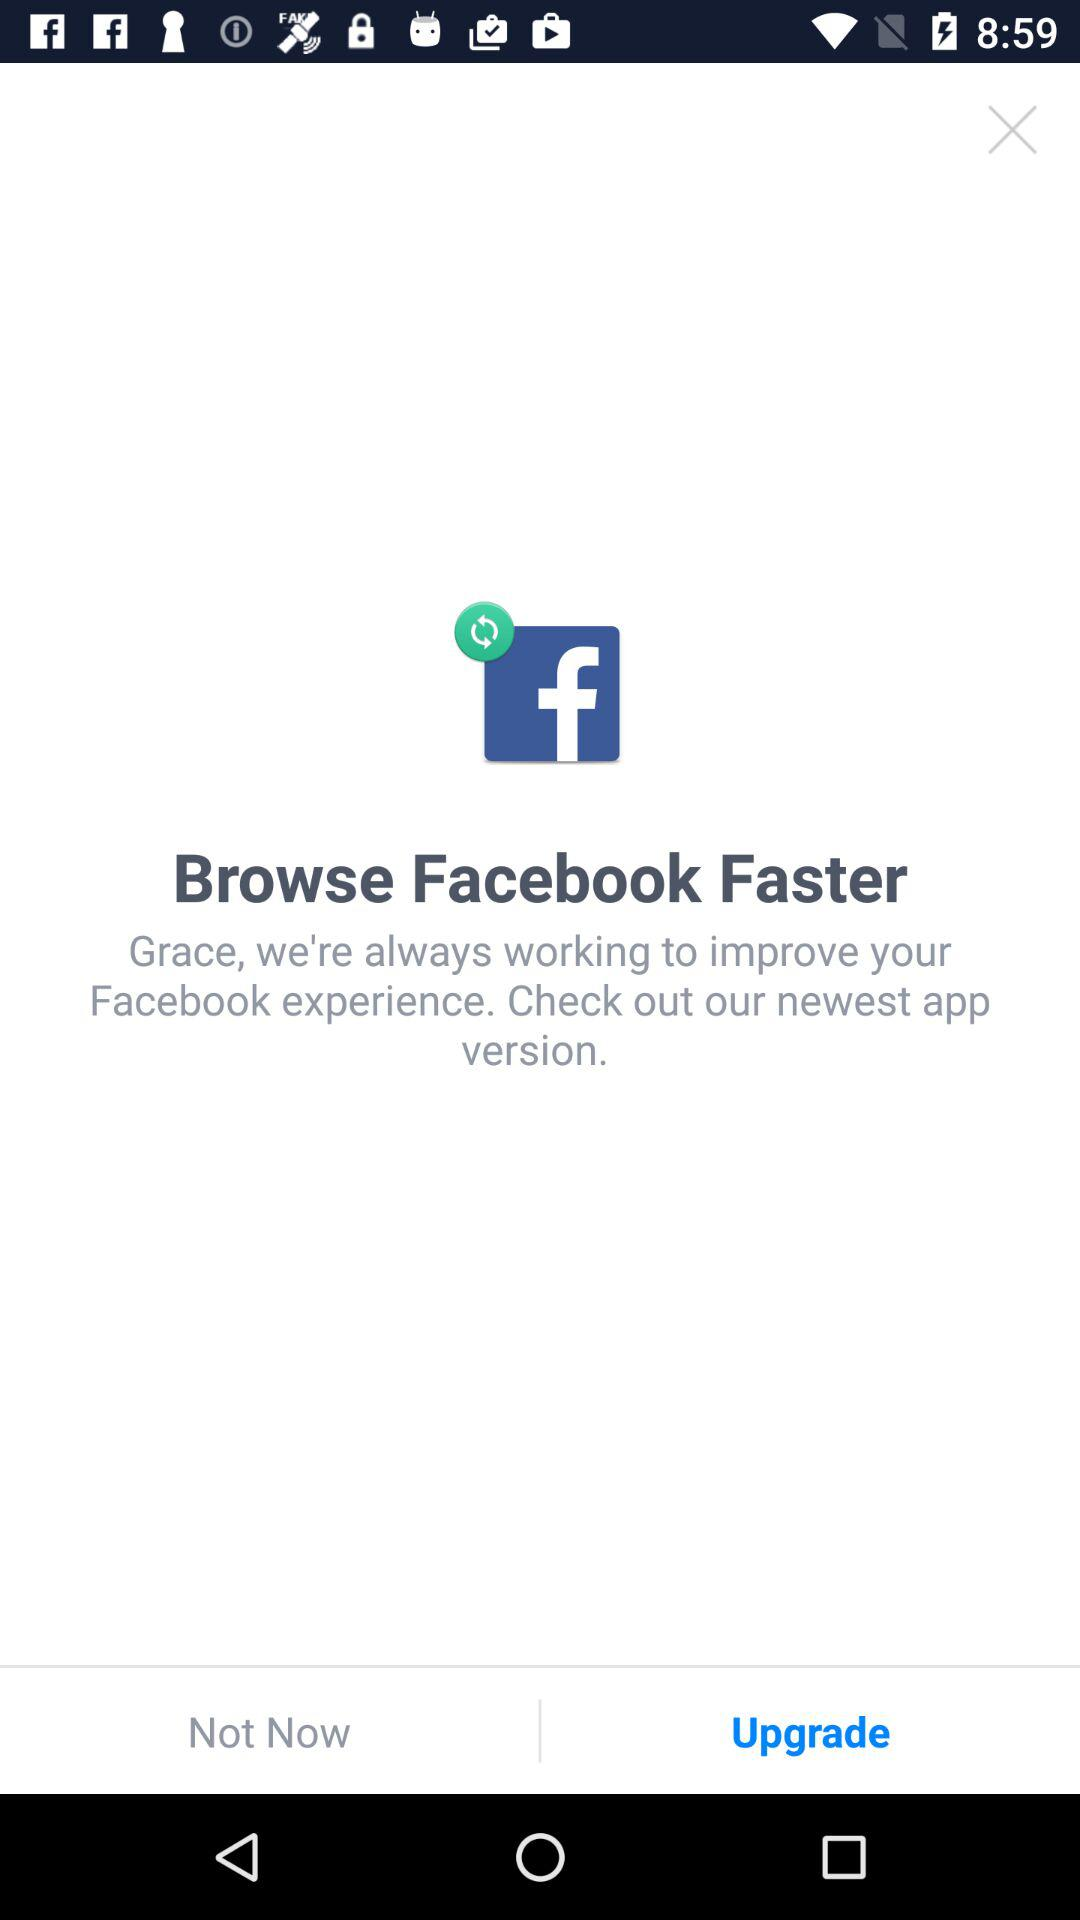What is the user name? The user name is Grace. 